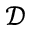<formula> <loc_0><loc_0><loc_500><loc_500>\mathcal { D }</formula> 